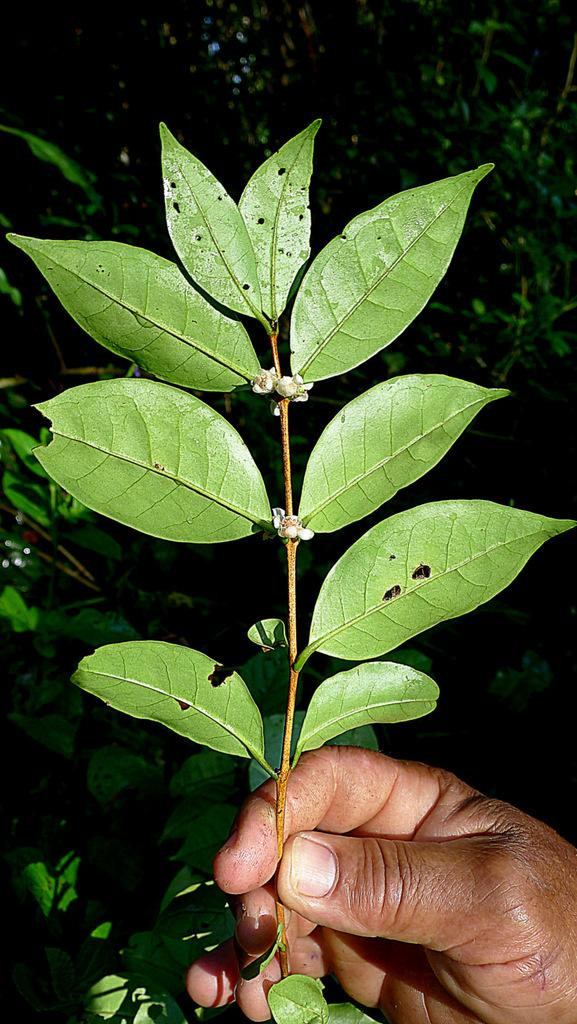What part of a person can be seen in the image? There is a person's hand in the image. What is the hand holding? The hand is holding a stem. What is attached to the stem? The stem has leaves on it. Are there any other leaves visible in the image? Yes, there are more leaves visible in the background. How would you describe the lighting in the image? The image appears to be a bit dark. What type of gold jewelry can be seen on the donkey in the image? There is no donkey or gold jewelry present in the image. 